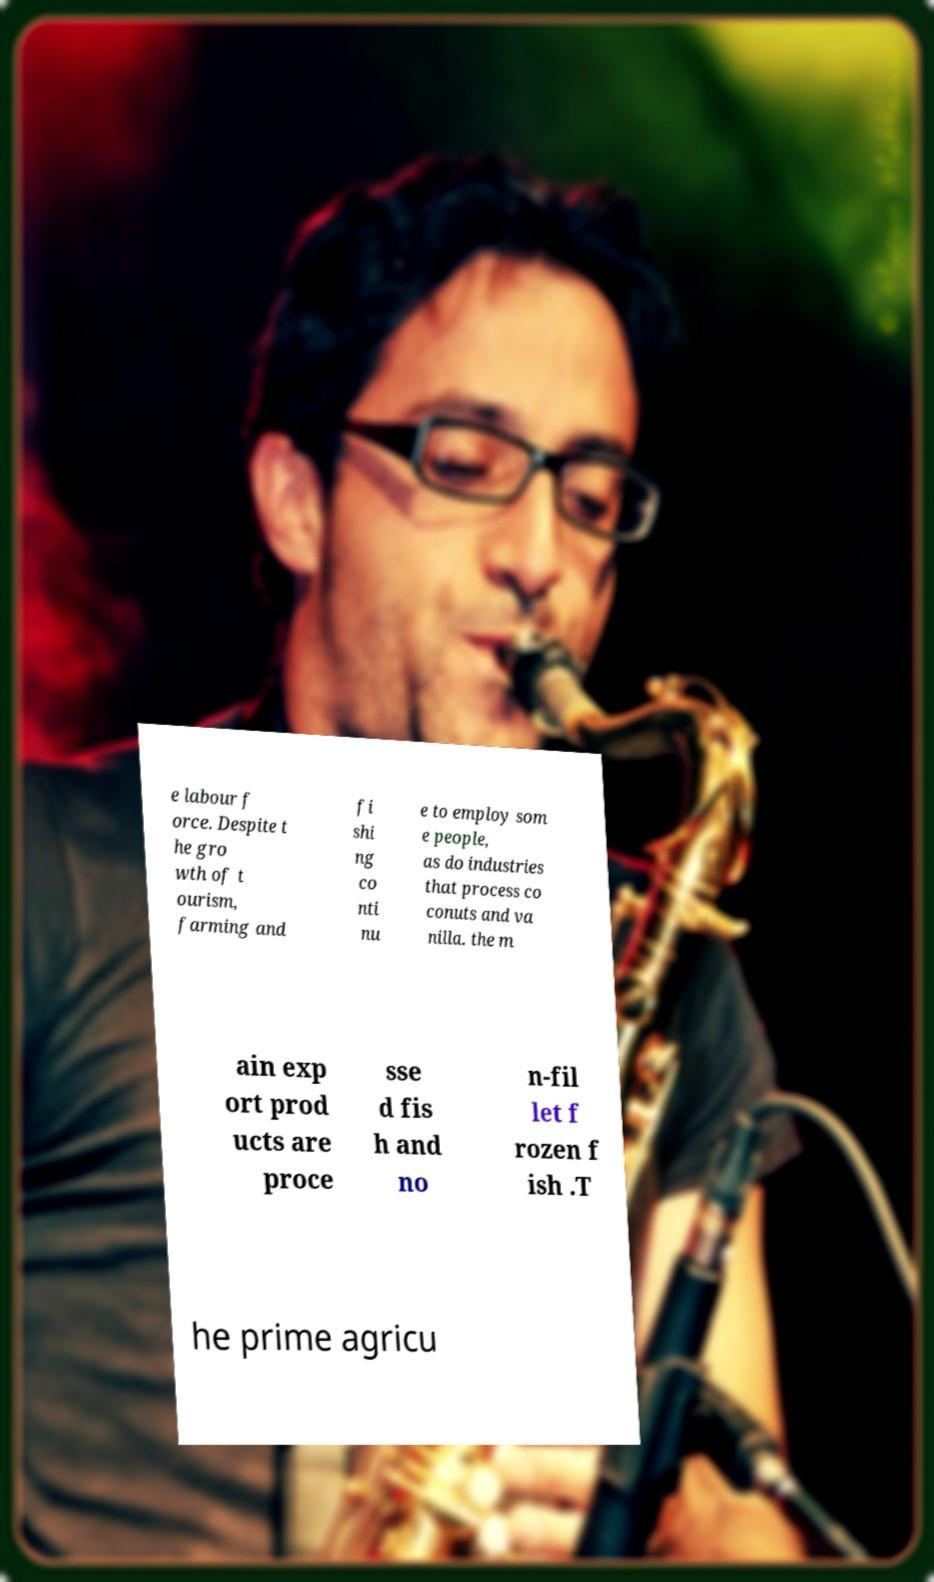For documentation purposes, I need the text within this image transcribed. Could you provide that? e labour f orce. Despite t he gro wth of t ourism, farming and fi shi ng co nti nu e to employ som e people, as do industries that process co conuts and va nilla. the m ain exp ort prod ucts are proce sse d fis h and no n-fil let f rozen f ish .T he prime agricu 